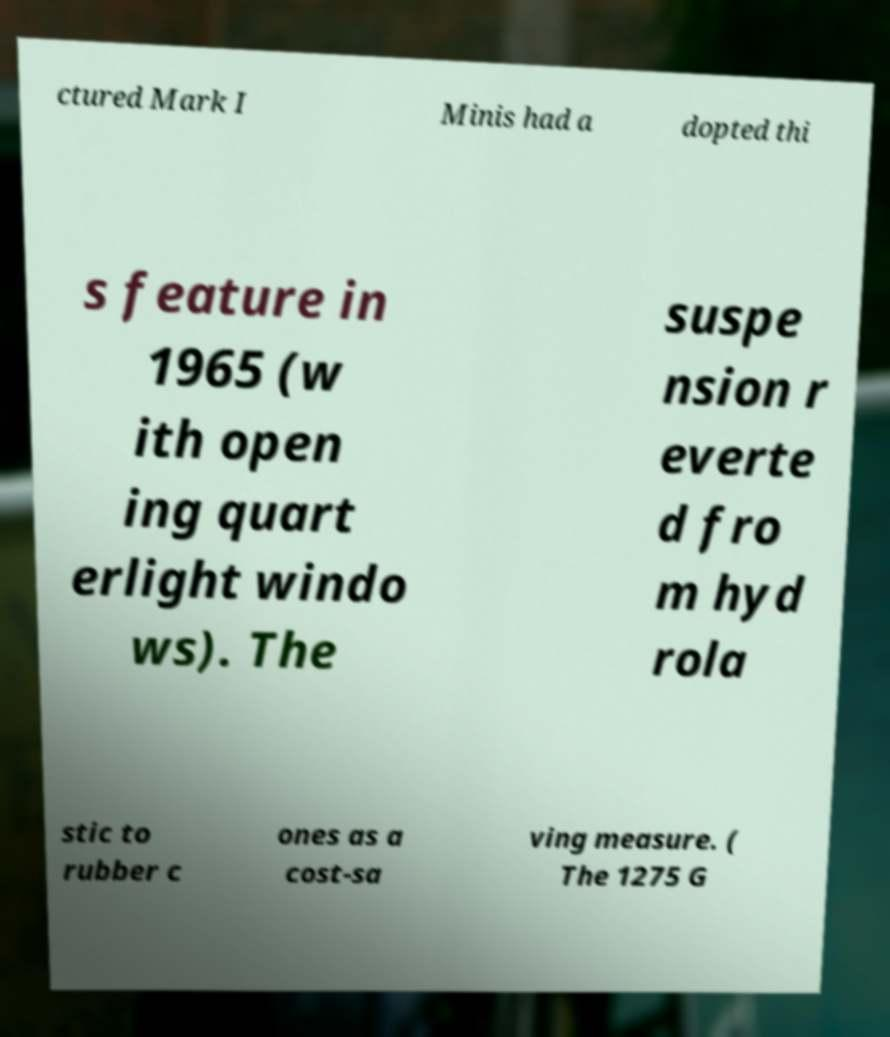Could you assist in decoding the text presented in this image and type it out clearly? ctured Mark I Minis had a dopted thi s feature in 1965 (w ith open ing quart erlight windo ws). The suspe nsion r everte d fro m hyd rola stic to rubber c ones as a cost-sa ving measure. ( The 1275 G 